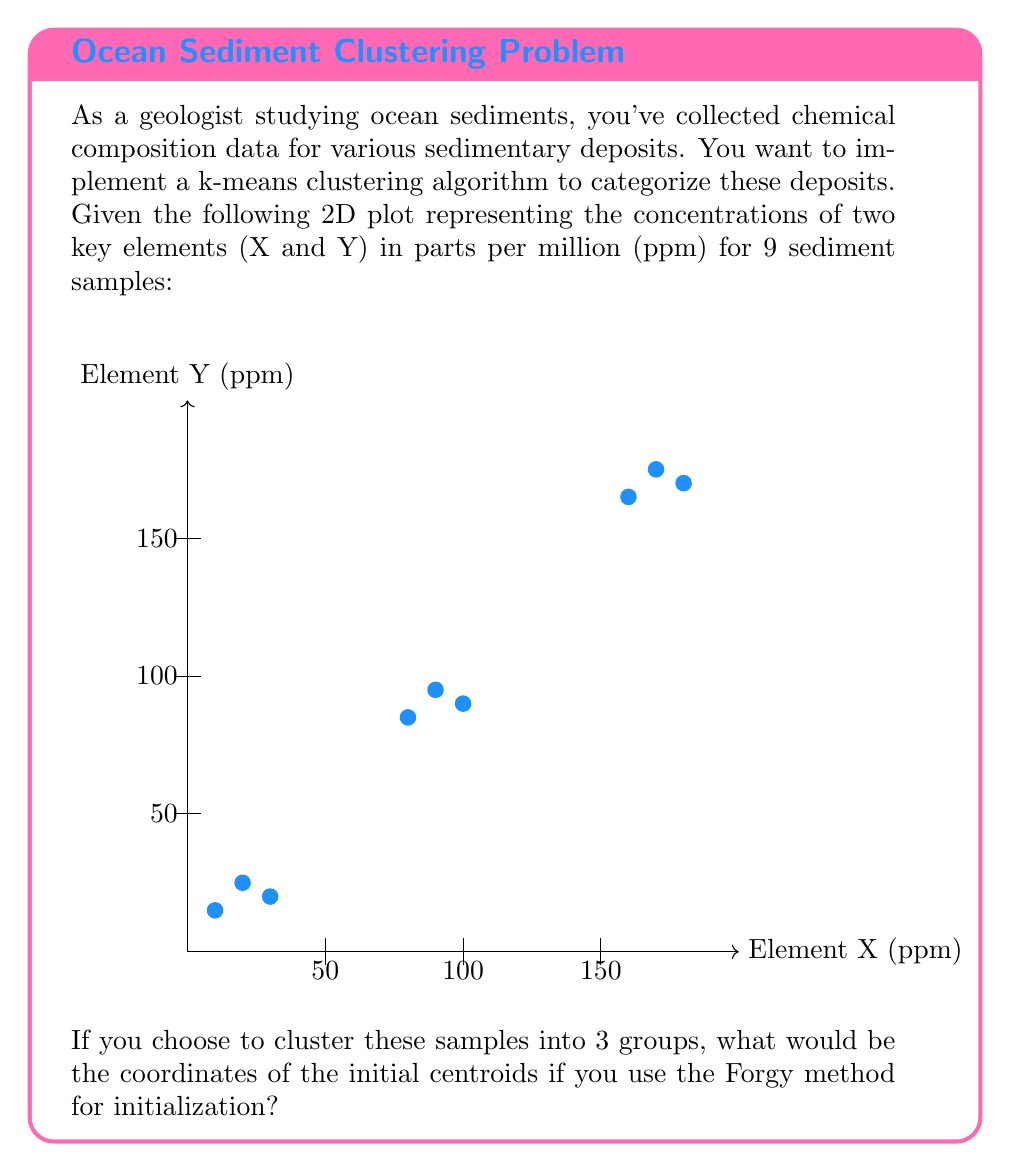Provide a solution to this math problem. To solve this problem, we need to understand the Forgy method for k-means initialization and apply it to our data:

1) The Forgy method initializes the centroids by randomly selecting k points from the dataset, where k is the number of clusters we want to create.

2) In this case, we want to create 3 clusters (k = 3).

3) To select 3 random points from our 9 data points, we can use a random number generator. For the sake of this example, let's say we randomly selected the 2nd, 5th, and 8th points.

4) The coordinates of these points are:
   2nd point: (20, 25)
   5th point: (90, 95)
   8th point: (170, 175)

5) These coordinates become our initial centroids for the k-means algorithm.

It's important to note that in practice, the random selection could result in different initial centroids. The purpose of this initialization is to provide a starting point for the iterative process of the k-means algorithm, which will then optimize the centroids' positions.
Answer: $$(20, 25), (90, 95), (170, 175)$$ 